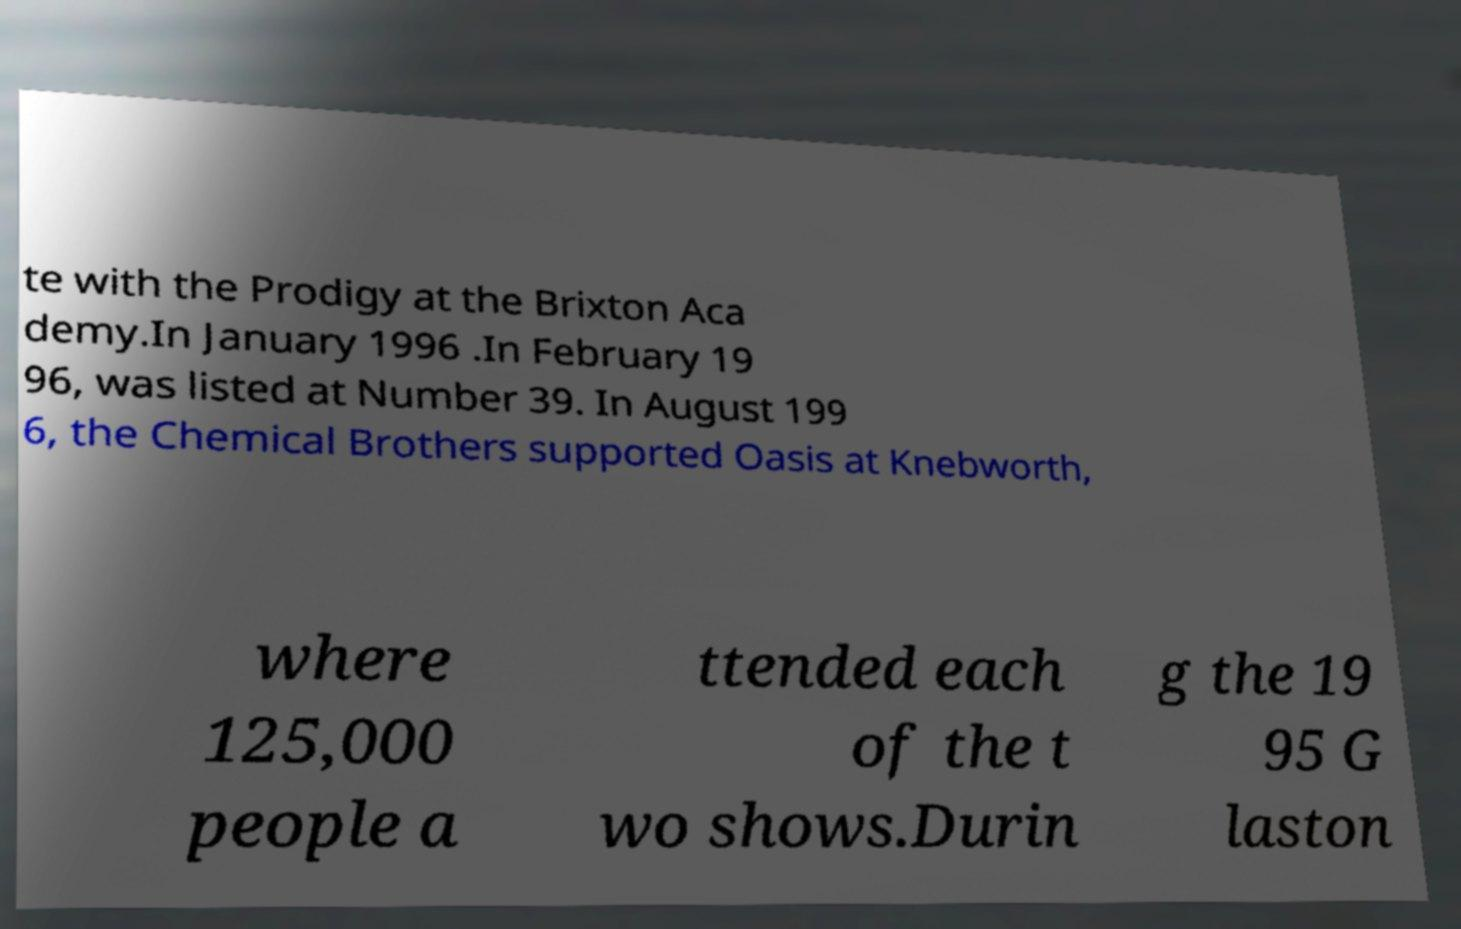For documentation purposes, I need the text within this image transcribed. Could you provide that? te with the Prodigy at the Brixton Aca demy.In January 1996 .In February 19 96, was listed at Number 39. In August 199 6, the Chemical Brothers supported Oasis at Knebworth, where 125,000 people a ttended each of the t wo shows.Durin g the 19 95 G laston 